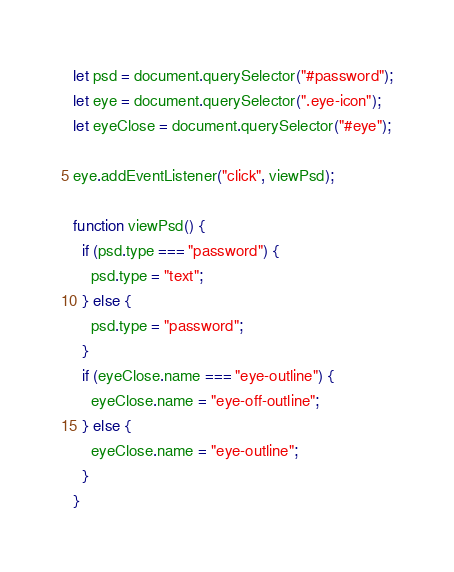Convert code to text. <code><loc_0><loc_0><loc_500><loc_500><_JavaScript_>let psd = document.querySelector("#password");
let eye = document.querySelector(".eye-icon");
let eyeClose = document.querySelector("#eye");

eye.addEventListener("click", viewPsd);

function viewPsd() {
  if (psd.type === "password") {
    psd.type = "text";
  } else {
    psd.type = "password";
  }
  if (eyeClose.name === "eye-outline") {
    eyeClose.name = "eye-off-outline";
  } else {
    eyeClose.name = "eye-outline";
  }
}
</code> 